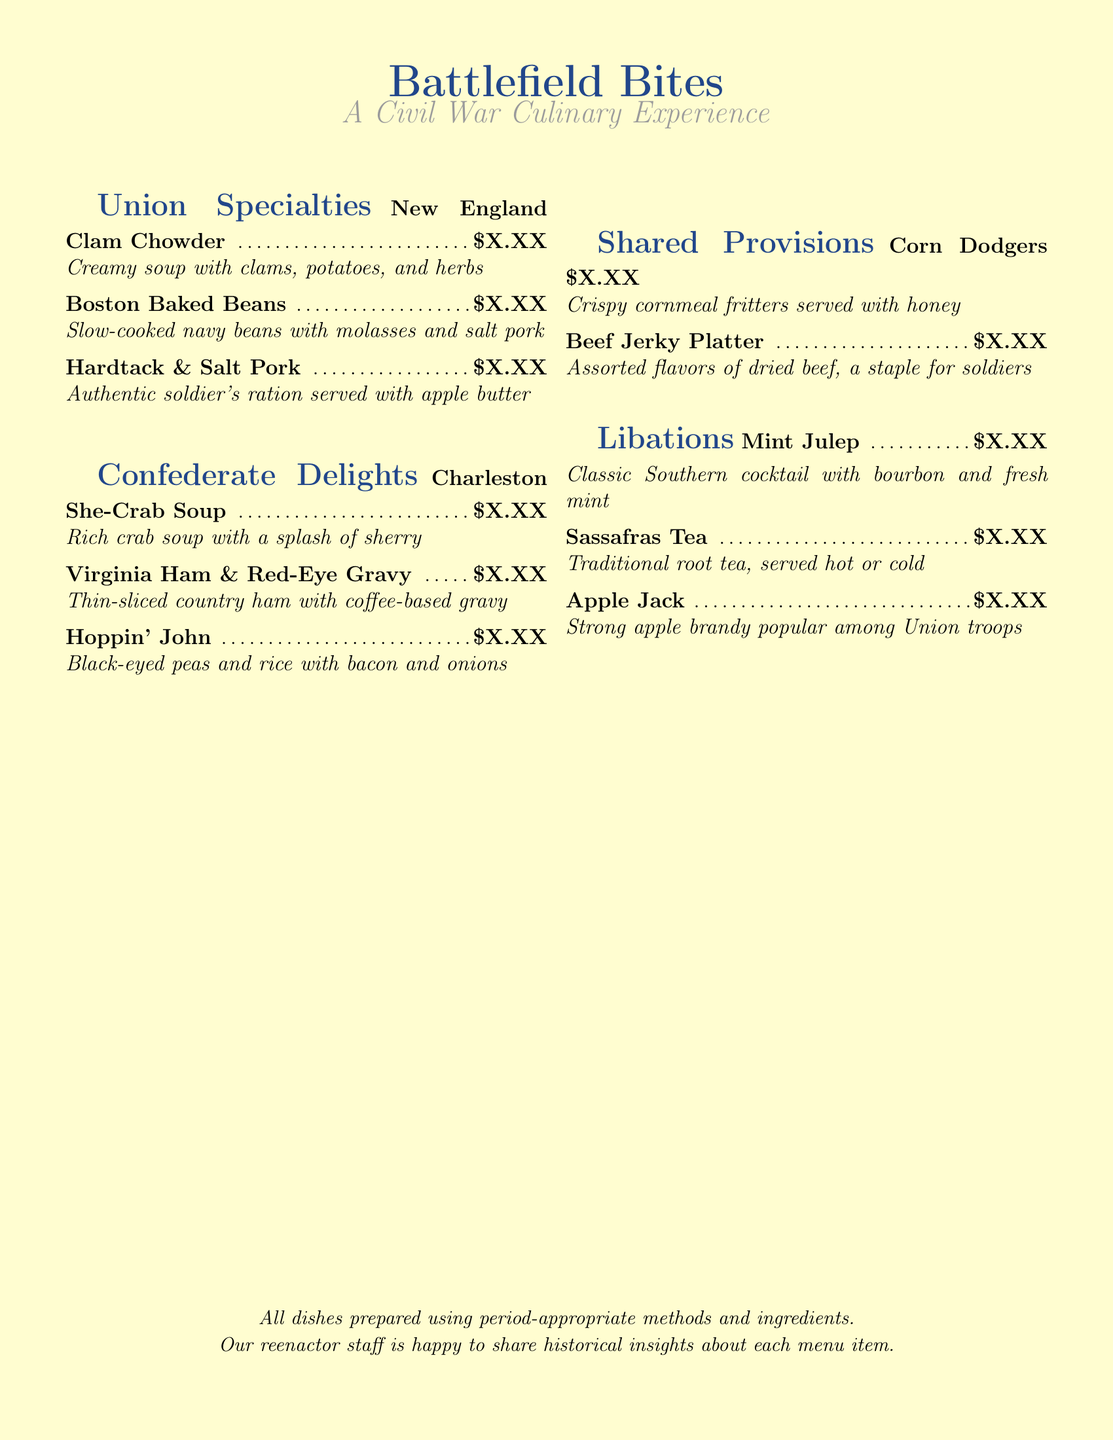What are the Union Specialties? The Union Specialties are listed in the menu section titled "Union Specialties."
Answer: New England Clam Chowder, Boston Baked Beans, Hardtack & Salt Pork What is Hoppin' John? Hoppin' John is included in the "Confederate Delights" section, citing its ingredients.
Answer: Black-eyed peas and rice with bacon and onions How many drink options are there? The drink options are listed in the "Libations" section.
Answer: Three What is the main ingredient in Charleston She-Crab Soup? The main ingredient is inferred from the name of the dish in the "Confederate Delights."
Answer: Crab What dish is served with apple butter? This dish is mentioned in the Union Specialties section as an authentic soldier's ration.
Answer: Hardtack & Salt Pork What type of cocktail is a Mint Julep? The type of cocktail is described in the "Libations" section.
Answer: Southern What are Corn Dodgers made from? The ingredients are implied from the name and description in the "Shared Provisions" section.
Answer: Cornmeal What is a unique feature of this restaurant's dishes? This detail is shared in the closing message of the document.
Answer: Period-appropriate methods and ingredients 